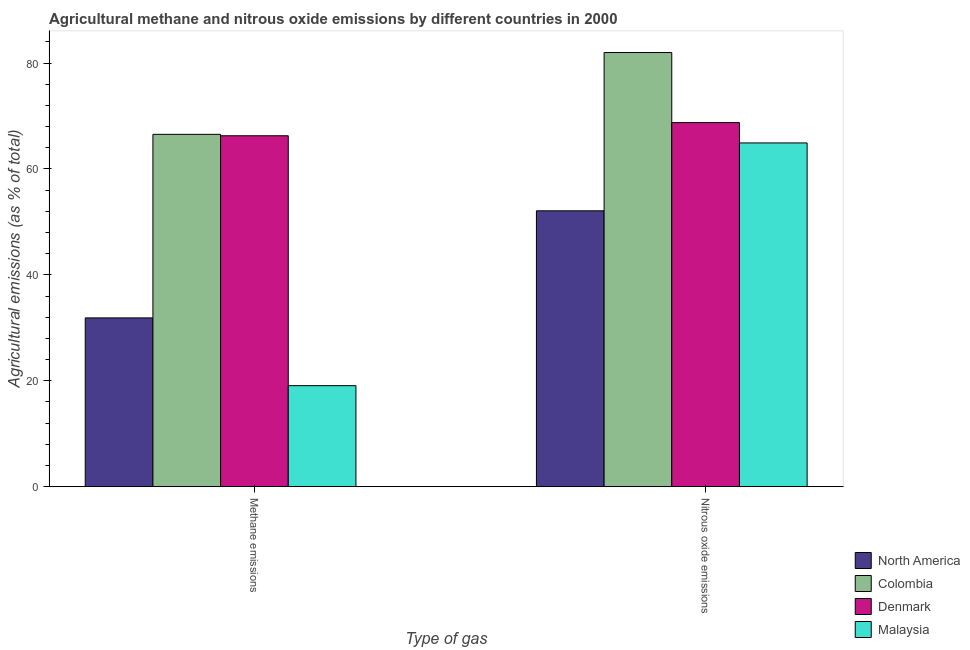How many different coloured bars are there?
Offer a very short reply. 4. How many groups of bars are there?
Offer a terse response. 2. Are the number of bars per tick equal to the number of legend labels?
Your answer should be very brief. Yes. How many bars are there on the 2nd tick from the right?
Your answer should be very brief. 4. What is the label of the 2nd group of bars from the left?
Keep it short and to the point. Nitrous oxide emissions. What is the amount of methane emissions in Denmark?
Offer a very short reply. 66.27. Across all countries, what is the maximum amount of nitrous oxide emissions?
Keep it short and to the point. 81.99. Across all countries, what is the minimum amount of methane emissions?
Give a very brief answer. 19.08. In which country was the amount of methane emissions minimum?
Offer a terse response. Malaysia. What is the total amount of nitrous oxide emissions in the graph?
Offer a very short reply. 267.77. What is the difference between the amount of nitrous oxide emissions in Denmark and that in Malaysia?
Your response must be concise. 3.84. What is the difference between the amount of methane emissions in Colombia and the amount of nitrous oxide emissions in Malaysia?
Your answer should be very brief. 1.62. What is the average amount of nitrous oxide emissions per country?
Your answer should be very brief. 66.94. What is the difference between the amount of methane emissions and amount of nitrous oxide emissions in North America?
Your response must be concise. -20.23. What is the ratio of the amount of nitrous oxide emissions in Colombia to that in Malaysia?
Offer a terse response. 1.26. What does the 1st bar from the left in Methane emissions represents?
Offer a very short reply. North America. What does the 1st bar from the right in Methane emissions represents?
Make the answer very short. Malaysia. How many bars are there?
Provide a short and direct response. 8. How many countries are there in the graph?
Offer a terse response. 4. What is the difference between two consecutive major ticks on the Y-axis?
Your response must be concise. 20. Are the values on the major ticks of Y-axis written in scientific E-notation?
Your answer should be very brief. No. Does the graph contain any zero values?
Keep it short and to the point. No. Does the graph contain grids?
Give a very brief answer. No. Where does the legend appear in the graph?
Your response must be concise. Bottom right. How many legend labels are there?
Ensure brevity in your answer.  4. How are the legend labels stacked?
Provide a succinct answer. Vertical. What is the title of the graph?
Offer a terse response. Agricultural methane and nitrous oxide emissions by different countries in 2000. What is the label or title of the X-axis?
Your answer should be compact. Type of gas. What is the label or title of the Y-axis?
Give a very brief answer. Agricultural emissions (as % of total). What is the Agricultural emissions (as % of total) of North America in Methane emissions?
Offer a very short reply. 31.88. What is the Agricultural emissions (as % of total) of Colombia in Methane emissions?
Offer a terse response. 66.54. What is the Agricultural emissions (as % of total) in Denmark in Methane emissions?
Your answer should be very brief. 66.27. What is the Agricultural emissions (as % of total) in Malaysia in Methane emissions?
Your answer should be very brief. 19.08. What is the Agricultural emissions (as % of total) of North America in Nitrous oxide emissions?
Give a very brief answer. 52.1. What is the Agricultural emissions (as % of total) of Colombia in Nitrous oxide emissions?
Your answer should be compact. 81.99. What is the Agricultural emissions (as % of total) of Denmark in Nitrous oxide emissions?
Provide a succinct answer. 68.76. What is the Agricultural emissions (as % of total) in Malaysia in Nitrous oxide emissions?
Provide a short and direct response. 64.92. Across all Type of gas, what is the maximum Agricultural emissions (as % of total) of North America?
Provide a short and direct response. 52.1. Across all Type of gas, what is the maximum Agricultural emissions (as % of total) in Colombia?
Make the answer very short. 81.99. Across all Type of gas, what is the maximum Agricultural emissions (as % of total) of Denmark?
Make the answer very short. 68.76. Across all Type of gas, what is the maximum Agricultural emissions (as % of total) in Malaysia?
Your answer should be very brief. 64.92. Across all Type of gas, what is the minimum Agricultural emissions (as % of total) in North America?
Ensure brevity in your answer.  31.88. Across all Type of gas, what is the minimum Agricultural emissions (as % of total) in Colombia?
Provide a succinct answer. 66.54. Across all Type of gas, what is the minimum Agricultural emissions (as % of total) in Denmark?
Give a very brief answer. 66.27. Across all Type of gas, what is the minimum Agricultural emissions (as % of total) in Malaysia?
Make the answer very short. 19.08. What is the total Agricultural emissions (as % of total) in North America in the graph?
Provide a short and direct response. 83.98. What is the total Agricultural emissions (as % of total) of Colombia in the graph?
Offer a very short reply. 148.53. What is the total Agricultural emissions (as % of total) in Denmark in the graph?
Provide a short and direct response. 135.03. What is the total Agricultural emissions (as % of total) in Malaysia in the graph?
Your answer should be compact. 84. What is the difference between the Agricultural emissions (as % of total) of North America in Methane emissions and that in Nitrous oxide emissions?
Provide a succinct answer. -20.23. What is the difference between the Agricultural emissions (as % of total) in Colombia in Methane emissions and that in Nitrous oxide emissions?
Your response must be concise. -15.45. What is the difference between the Agricultural emissions (as % of total) in Denmark in Methane emissions and that in Nitrous oxide emissions?
Provide a succinct answer. -2.49. What is the difference between the Agricultural emissions (as % of total) of Malaysia in Methane emissions and that in Nitrous oxide emissions?
Provide a short and direct response. -45.84. What is the difference between the Agricultural emissions (as % of total) in North America in Methane emissions and the Agricultural emissions (as % of total) in Colombia in Nitrous oxide emissions?
Offer a terse response. -50.11. What is the difference between the Agricultural emissions (as % of total) in North America in Methane emissions and the Agricultural emissions (as % of total) in Denmark in Nitrous oxide emissions?
Your answer should be very brief. -36.88. What is the difference between the Agricultural emissions (as % of total) in North America in Methane emissions and the Agricultural emissions (as % of total) in Malaysia in Nitrous oxide emissions?
Give a very brief answer. -33.04. What is the difference between the Agricultural emissions (as % of total) of Colombia in Methane emissions and the Agricultural emissions (as % of total) of Denmark in Nitrous oxide emissions?
Provide a short and direct response. -2.21. What is the difference between the Agricultural emissions (as % of total) of Colombia in Methane emissions and the Agricultural emissions (as % of total) of Malaysia in Nitrous oxide emissions?
Your answer should be compact. 1.62. What is the difference between the Agricultural emissions (as % of total) in Denmark in Methane emissions and the Agricultural emissions (as % of total) in Malaysia in Nitrous oxide emissions?
Your answer should be compact. 1.35. What is the average Agricultural emissions (as % of total) of North America per Type of gas?
Make the answer very short. 41.99. What is the average Agricultural emissions (as % of total) in Colombia per Type of gas?
Provide a short and direct response. 74.27. What is the average Agricultural emissions (as % of total) of Denmark per Type of gas?
Your response must be concise. 67.52. What is the average Agricultural emissions (as % of total) in Malaysia per Type of gas?
Provide a succinct answer. 42. What is the difference between the Agricultural emissions (as % of total) in North America and Agricultural emissions (as % of total) in Colombia in Methane emissions?
Ensure brevity in your answer.  -34.67. What is the difference between the Agricultural emissions (as % of total) in North America and Agricultural emissions (as % of total) in Denmark in Methane emissions?
Keep it short and to the point. -34.4. What is the difference between the Agricultural emissions (as % of total) of North America and Agricultural emissions (as % of total) of Malaysia in Methane emissions?
Offer a terse response. 12.8. What is the difference between the Agricultural emissions (as % of total) in Colombia and Agricultural emissions (as % of total) in Denmark in Methane emissions?
Offer a very short reply. 0.27. What is the difference between the Agricultural emissions (as % of total) in Colombia and Agricultural emissions (as % of total) in Malaysia in Methane emissions?
Your answer should be very brief. 47.46. What is the difference between the Agricultural emissions (as % of total) of Denmark and Agricultural emissions (as % of total) of Malaysia in Methane emissions?
Offer a very short reply. 47.19. What is the difference between the Agricultural emissions (as % of total) of North America and Agricultural emissions (as % of total) of Colombia in Nitrous oxide emissions?
Keep it short and to the point. -29.89. What is the difference between the Agricultural emissions (as % of total) of North America and Agricultural emissions (as % of total) of Denmark in Nitrous oxide emissions?
Your answer should be very brief. -16.66. What is the difference between the Agricultural emissions (as % of total) in North America and Agricultural emissions (as % of total) in Malaysia in Nitrous oxide emissions?
Give a very brief answer. -12.82. What is the difference between the Agricultural emissions (as % of total) of Colombia and Agricultural emissions (as % of total) of Denmark in Nitrous oxide emissions?
Offer a very short reply. 13.23. What is the difference between the Agricultural emissions (as % of total) of Colombia and Agricultural emissions (as % of total) of Malaysia in Nitrous oxide emissions?
Your answer should be very brief. 17.07. What is the difference between the Agricultural emissions (as % of total) in Denmark and Agricultural emissions (as % of total) in Malaysia in Nitrous oxide emissions?
Your answer should be compact. 3.84. What is the ratio of the Agricultural emissions (as % of total) in North America in Methane emissions to that in Nitrous oxide emissions?
Offer a terse response. 0.61. What is the ratio of the Agricultural emissions (as % of total) of Colombia in Methane emissions to that in Nitrous oxide emissions?
Ensure brevity in your answer.  0.81. What is the ratio of the Agricultural emissions (as % of total) in Denmark in Methane emissions to that in Nitrous oxide emissions?
Offer a very short reply. 0.96. What is the ratio of the Agricultural emissions (as % of total) in Malaysia in Methane emissions to that in Nitrous oxide emissions?
Offer a very short reply. 0.29. What is the difference between the highest and the second highest Agricultural emissions (as % of total) in North America?
Your response must be concise. 20.23. What is the difference between the highest and the second highest Agricultural emissions (as % of total) of Colombia?
Your answer should be very brief. 15.45. What is the difference between the highest and the second highest Agricultural emissions (as % of total) in Denmark?
Offer a very short reply. 2.49. What is the difference between the highest and the second highest Agricultural emissions (as % of total) of Malaysia?
Give a very brief answer. 45.84. What is the difference between the highest and the lowest Agricultural emissions (as % of total) in North America?
Your response must be concise. 20.23. What is the difference between the highest and the lowest Agricultural emissions (as % of total) in Colombia?
Your answer should be compact. 15.45. What is the difference between the highest and the lowest Agricultural emissions (as % of total) in Denmark?
Make the answer very short. 2.49. What is the difference between the highest and the lowest Agricultural emissions (as % of total) in Malaysia?
Your answer should be very brief. 45.84. 